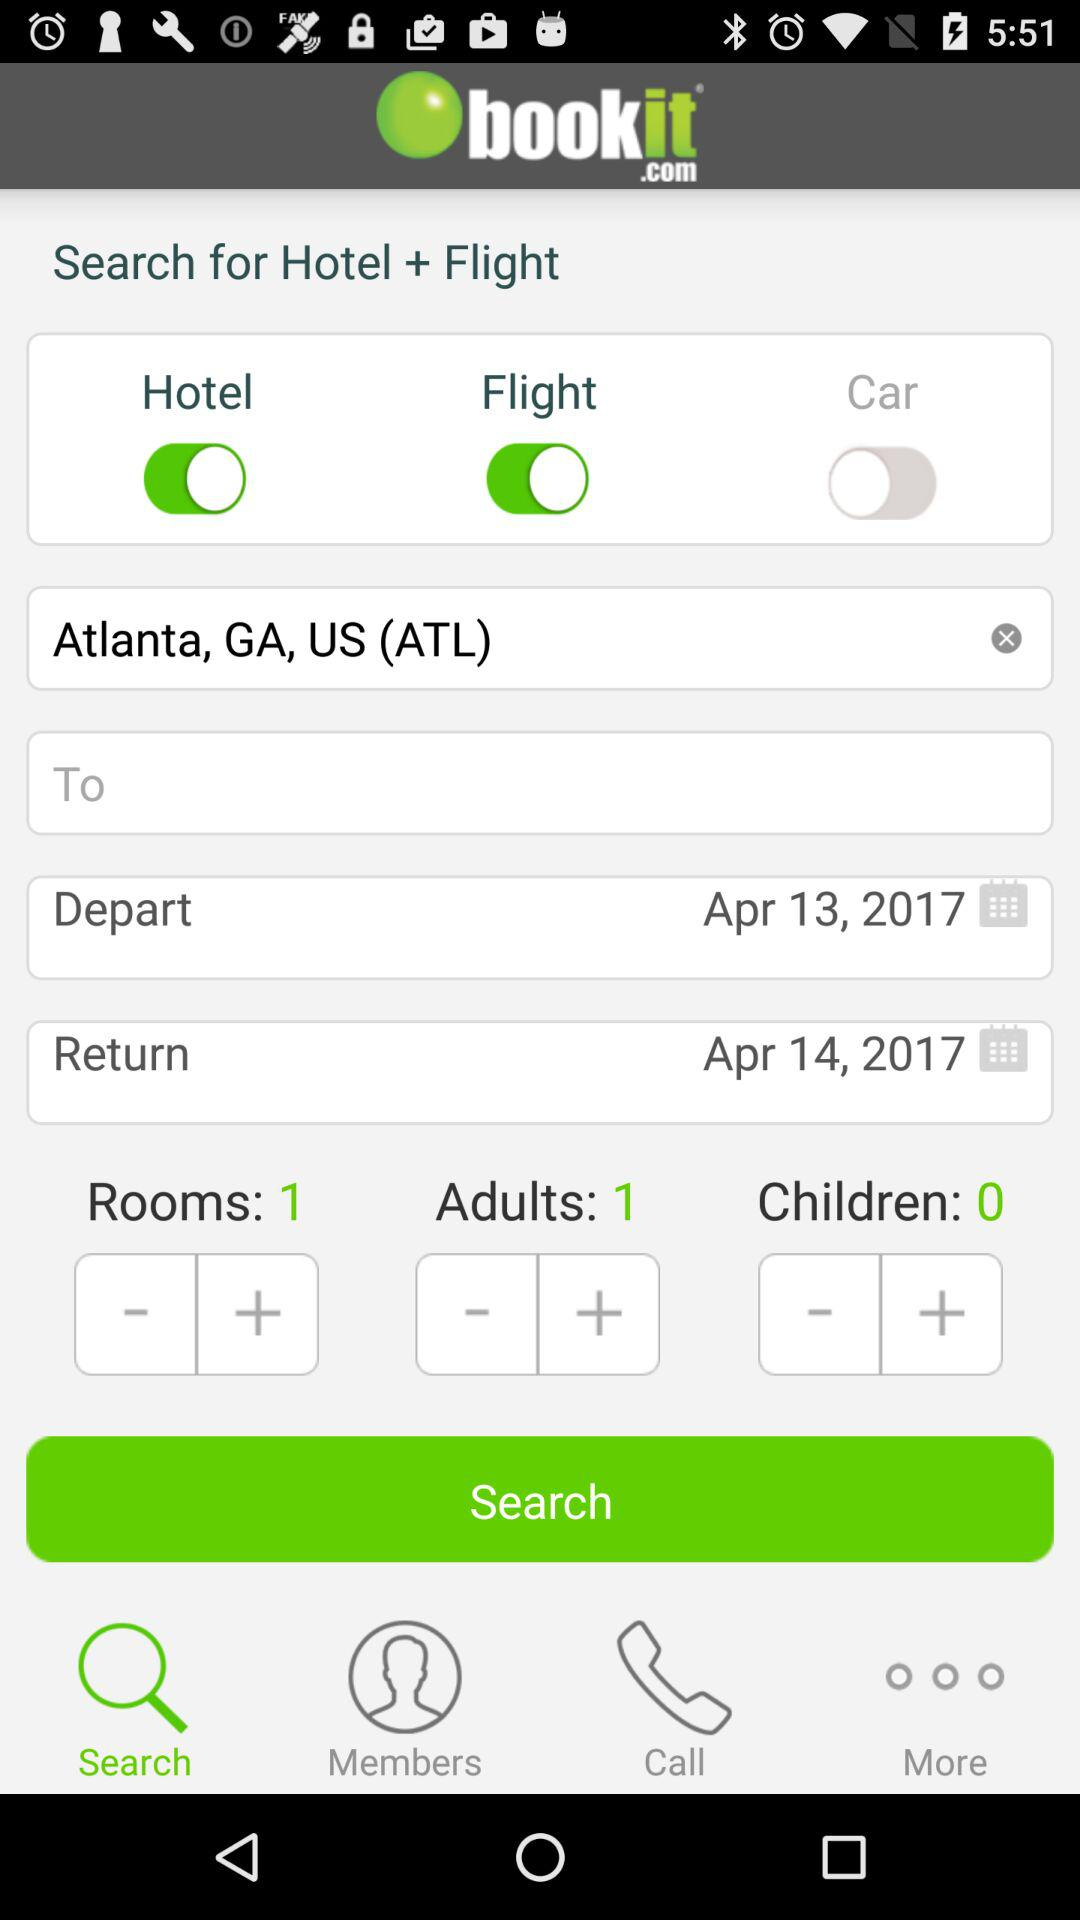How many adults are the user searching for?
Answer the question using a single word or phrase. 1 